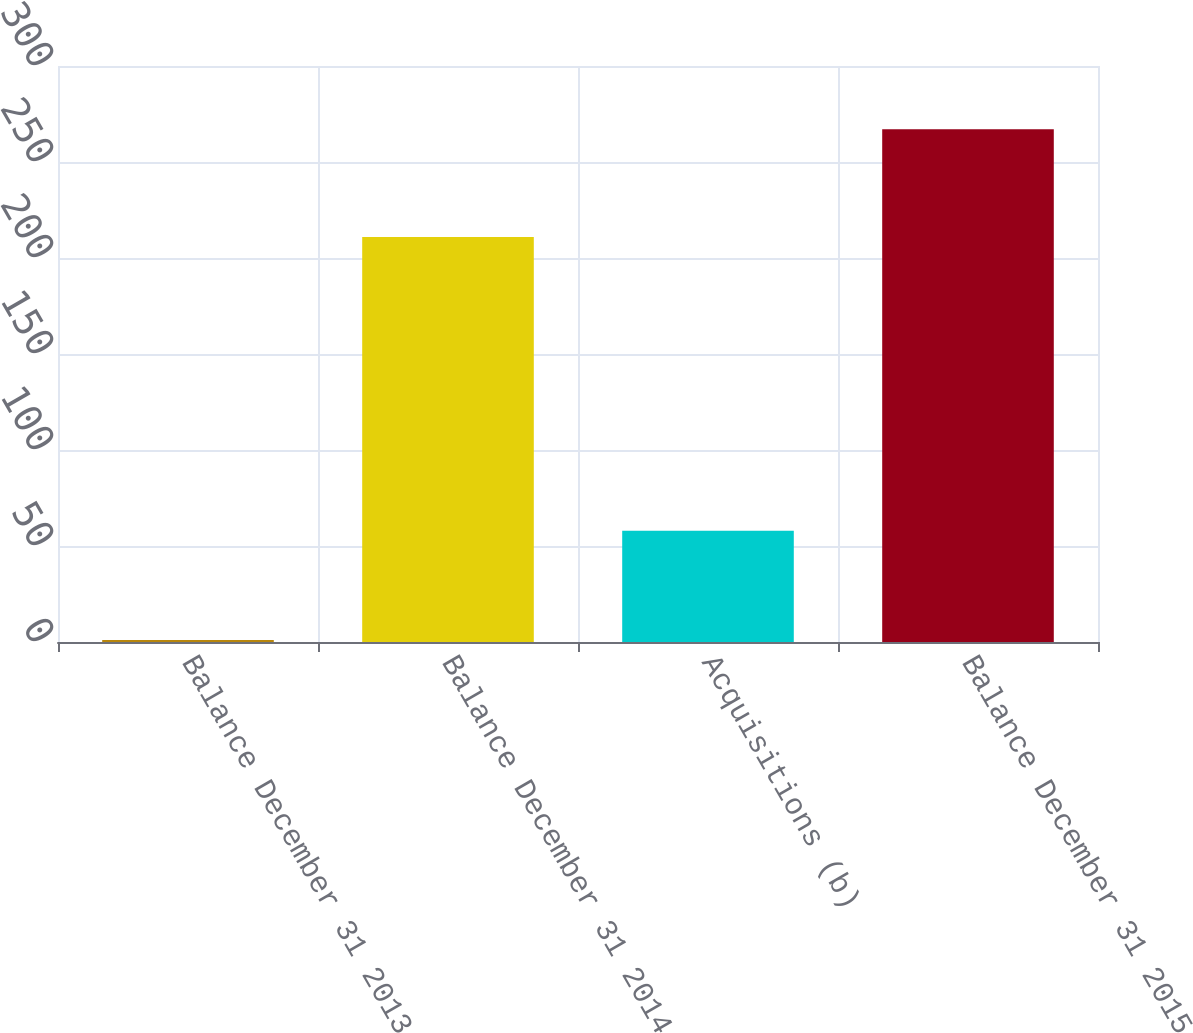Convert chart to OTSL. <chart><loc_0><loc_0><loc_500><loc_500><bar_chart><fcel>Balance December 31 2013<fcel>Balance December 31 2014<fcel>Acquisitions (b)<fcel>Balance December 31 2015<nl><fcel>1<fcel>211<fcel>58<fcel>267<nl></chart> 